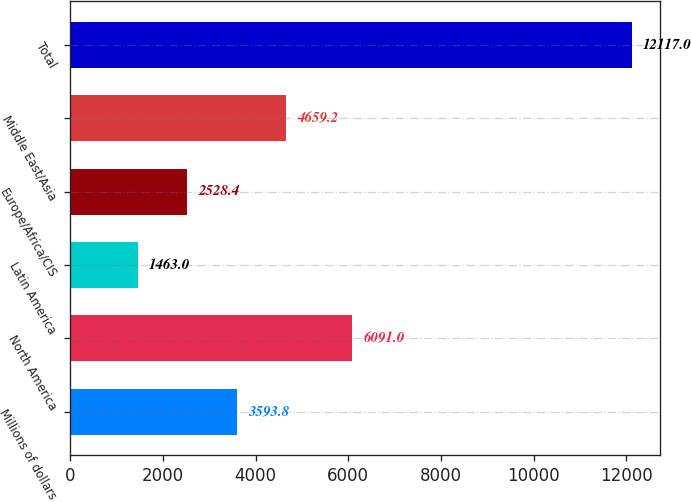Convert chart to OTSL. <chart><loc_0><loc_0><loc_500><loc_500><bar_chart><fcel>Millions of dollars<fcel>North America<fcel>Latin America<fcel>Europe/Africa/CIS<fcel>Middle East/Asia<fcel>Total<nl><fcel>3593.8<fcel>6091<fcel>1463<fcel>2528.4<fcel>4659.2<fcel>12117<nl></chart> 